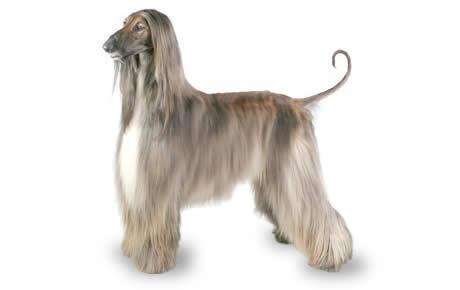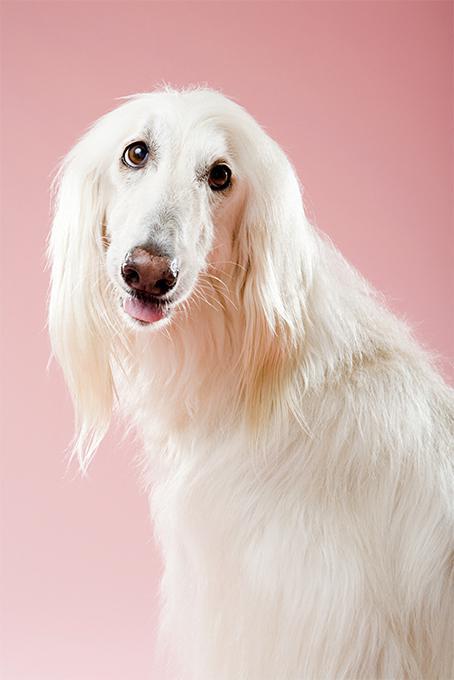The first image is the image on the left, the second image is the image on the right. Analyze the images presented: Is the assertion "The right image has a dog standing on a grassy surface" valid? Answer yes or no. No. The first image is the image on the left, the second image is the image on the right. Examine the images to the left and right. Is the description "The dog in the left image is standing on snow-covered ground." accurate? Answer yes or no. No. 